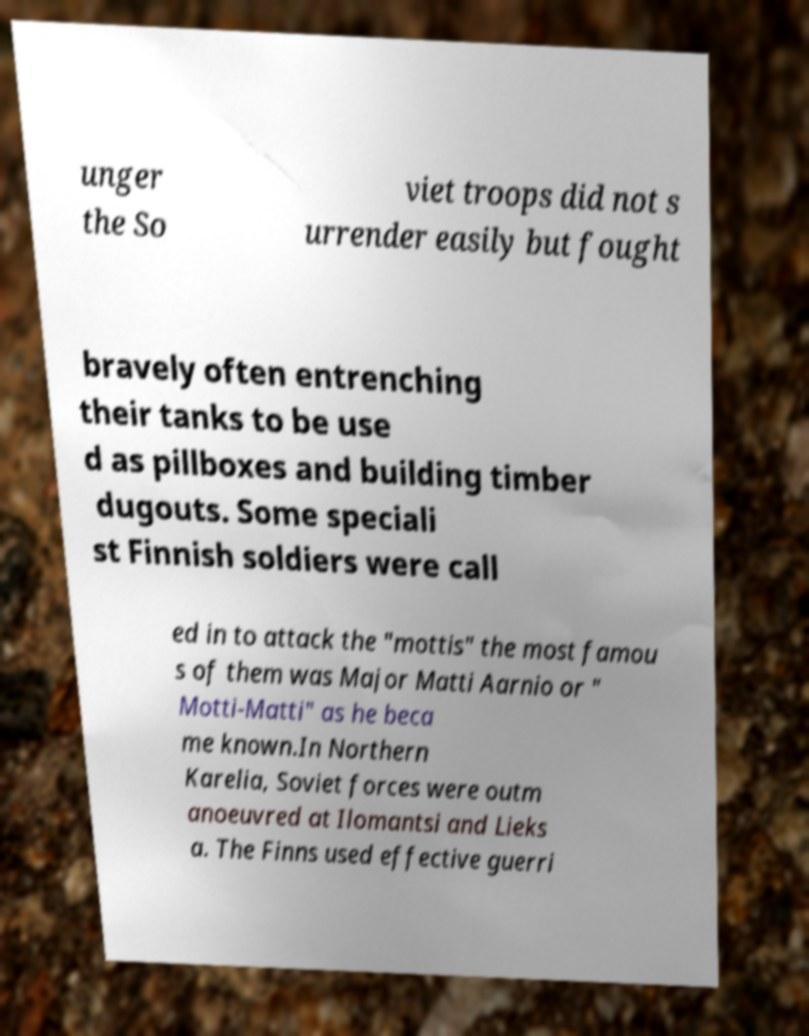Please read and relay the text visible in this image. What does it say? unger the So viet troops did not s urrender easily but fought bravely often entrenching their tanks to be use d as pillboxes and building timber dugouts. Some speciali st Finnish soldiers were call ed in to attack the "mottis" the most famou s of them was Major Matti Aarnio or " Motti-Matti" as he beca me known.In Northern Karelia, Soviet forces were outm anoeuvred at Ilomantsi and Lieks a. The Finns used effective guerri 